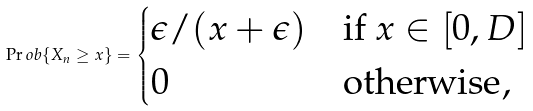Convert formula to latex. <formula><loc_0><loc_0><loc_500><loc_500>\Pr o b \{ X _ { n } \geq x \} = \begin{cases} \epsilon / ( x + \epsilon ) & \text {if $x\in[0,D]$} \\ 0 & \text {otherwise} , \end{cases}</formula> 